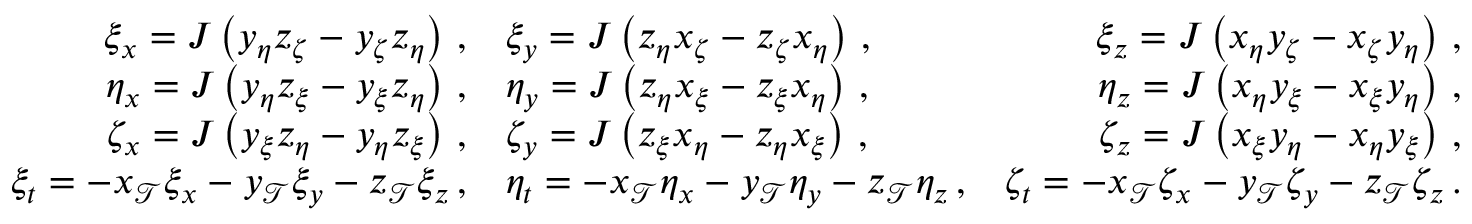Convert formula to latex. <formula><loc_0><loc_0><loc_500><loc_500>\begin{array} { r l r } { \xi _ { x } = J \left ( y _ { \eta } z _ { \zeta } - y _ { \zeta } z _ { \eta } \right ) \, , } & { \xi _ { y } = J \left ( z _ { \eta } x _ { \zeta } - z _ { \zeta } x _ { \eta } \right ) \, , } & { \xi _ { z } = J \left ( x _ { \eta } y _ { \zeta } - x _ { \zeta } y _ { \eta } \right ) \, , } \\ { \eta _ { x } = J \left ( y _ { \eta } z _ { \xi } - y _ { \xi } z _ { \eta } \right ) \, , } & { \eta _ { y } = J \left ( z _ { \eta } x _ { \xi } - z _ { \xi } x _ { \eta } \right ) \, , } & { \eta _ { z } = J \left ( x _ { \eta } y _ { \xi } - x _ { \xi } y _ { \eta } \right ) \, , } \\ { \zeta _ { x } = J \left ( y _ { \xi } z _ { \eta } - y _ { \eta } z _ { \xi } \right ) \, , } & { \zeta _ { y } = J \left ( z _ { \xi } x _ { \eta } - z _ { \eta } x _ { \xi } \right ) \, , } & { \zeta _ { z } = J \left ( x _ { \xi } y _ { \eta } - x _ { \eta } y _ { \xi } \right ) \, , } \\ { \xi _ { t } = - x _ { \mathcal { T } } \xi _ { x } - y _ { \mathcal { T } } \xi _ { y } - z _ { \mathcal { T } } \xi _ { z } \, , } & { \eta _ { t } = - x _ { \mathcal { T } } \eta _ { x } - y _ { \mathcal { T } } \eta _ { y } - z _ { \mathcal { T } } \eta _ { z } \, , } & { \zeta _ { t } = - x _ { \mathcal { T } } \zeta _ { x } - y _ { \mathcal { T } } \zeta _ { y } - z _ { \mathcal { T } } \zeta _ { z } \, . } \end{array}</formula> 